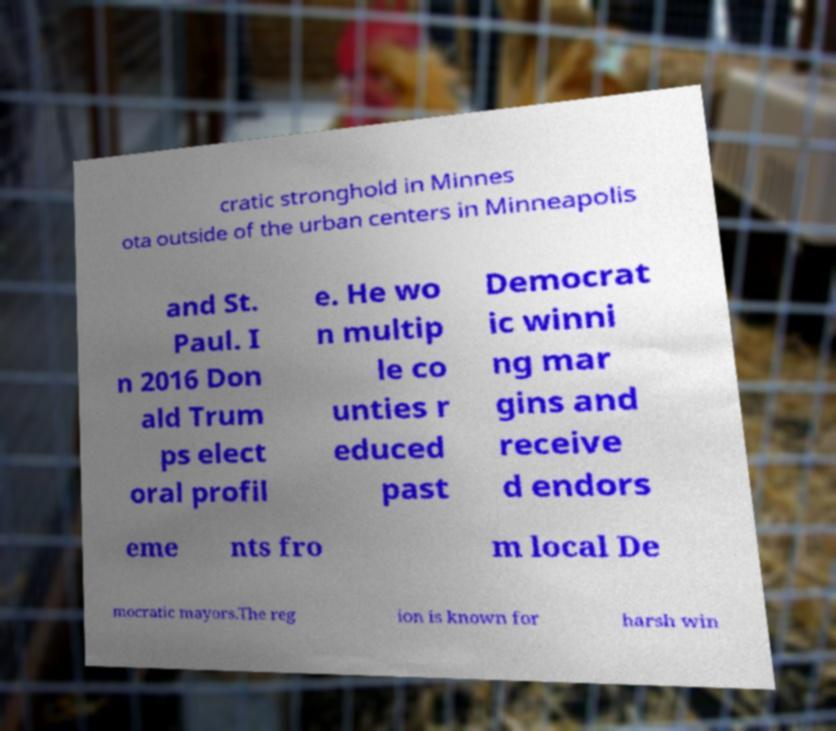Can you accurately transcribe the text from the provided image for me? cratic stronghold in Minnes ota outside of the urban centers in Minneapolis and St. Paul. I n 2016 Don ald Trum ps elect oral profil e. He wo n multip le co unties r educed past Democrat ic winni ng mar gins and receive d endors eme nts fro m local De mocratic mayors.The reg ion is known for harsh win 